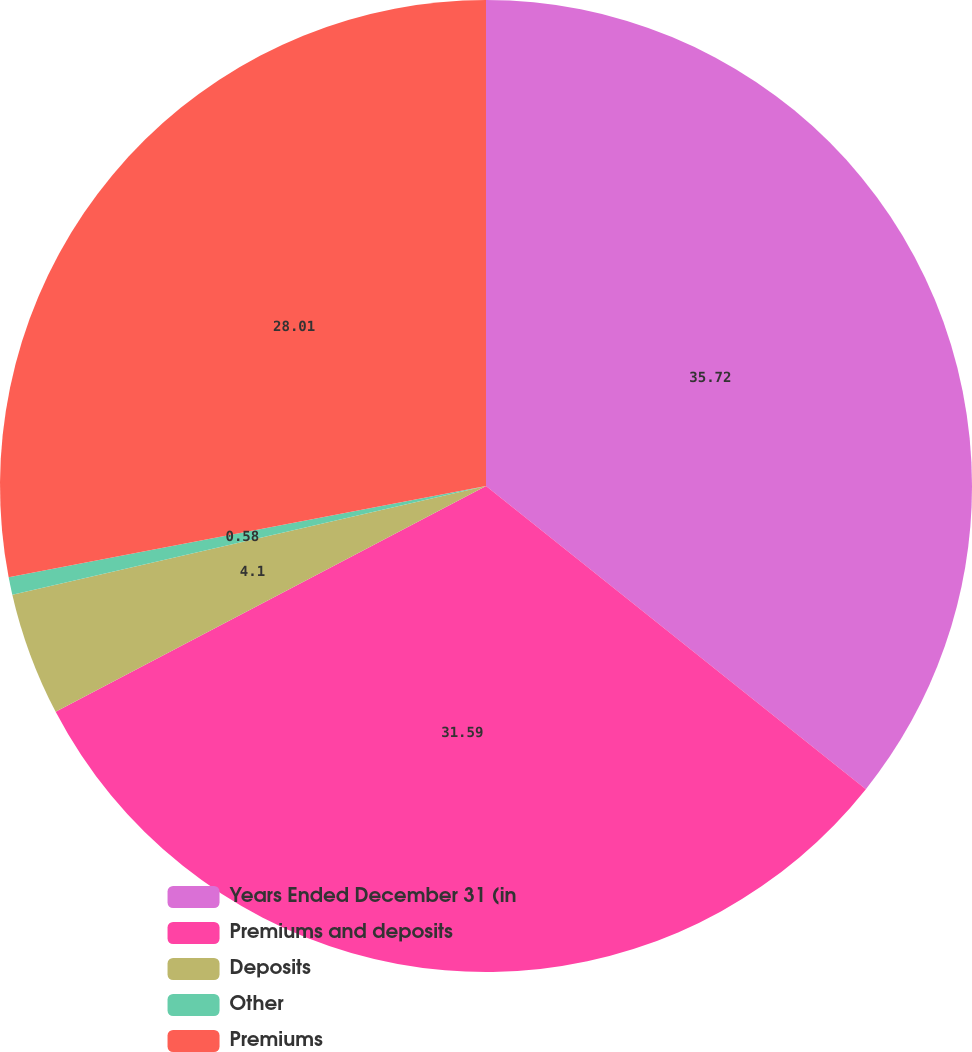<chart> <loc_0><loc_0><loc_500><loc_500><pie_chart><fcel>Years Ended December 31 (in<fcel>Premiums and deposits<fcel>Deposits<fcel>Other<fcel>Premiums<nl><fcel>35.72%<fcel>31.59%<fcel>4.1%<fcel>0.58%<fcel>28.01%<nl></chart> 